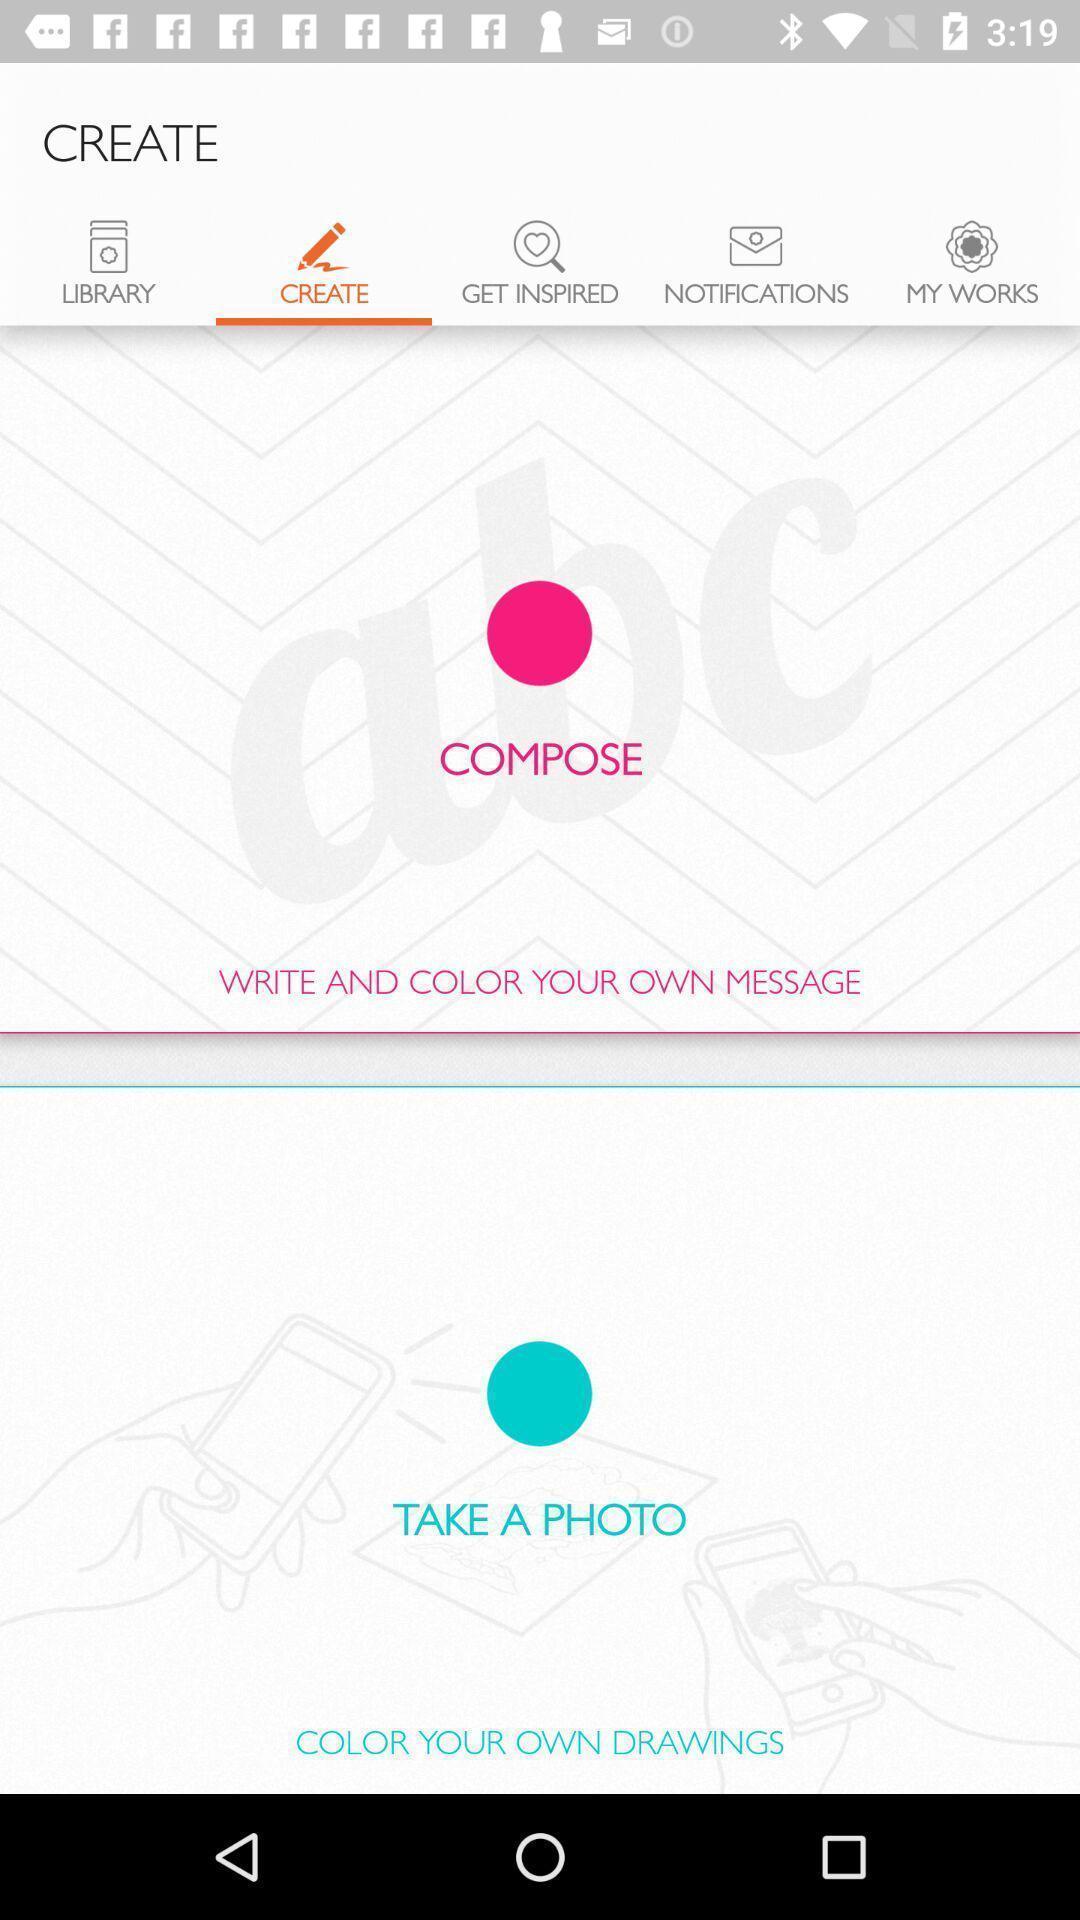Describe this image in words. Screen display create page. 